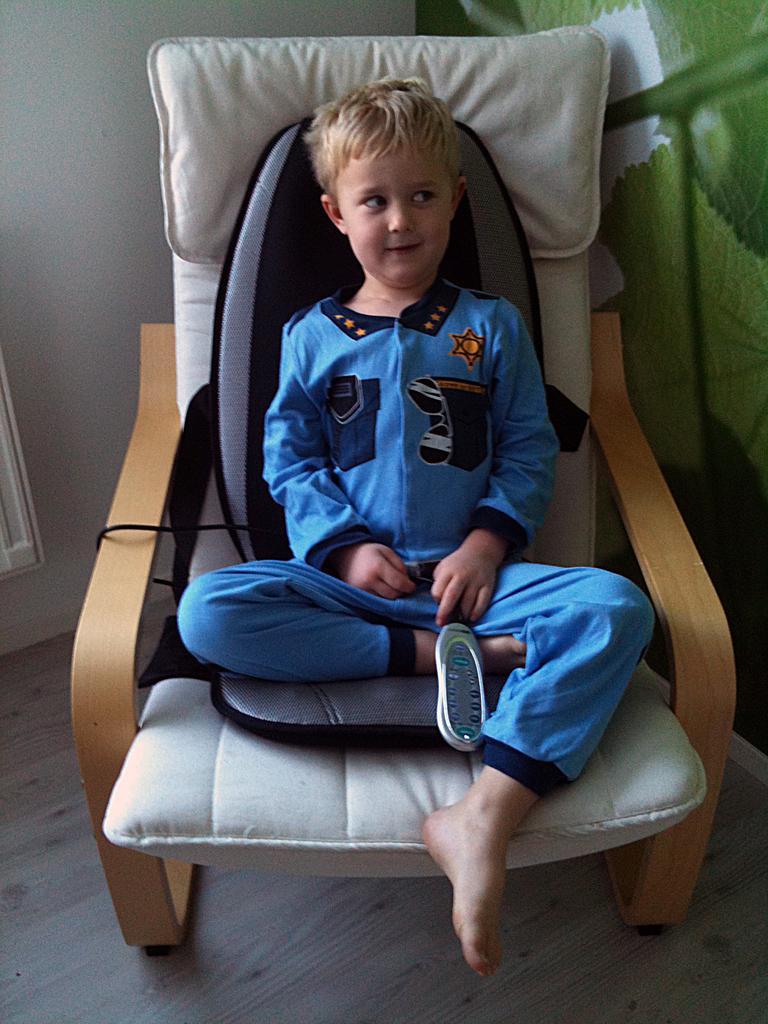How would you summarize this image in a sentence or two? In this image there is a chair on which a kid is sitting. He is wearing blue color dress. 